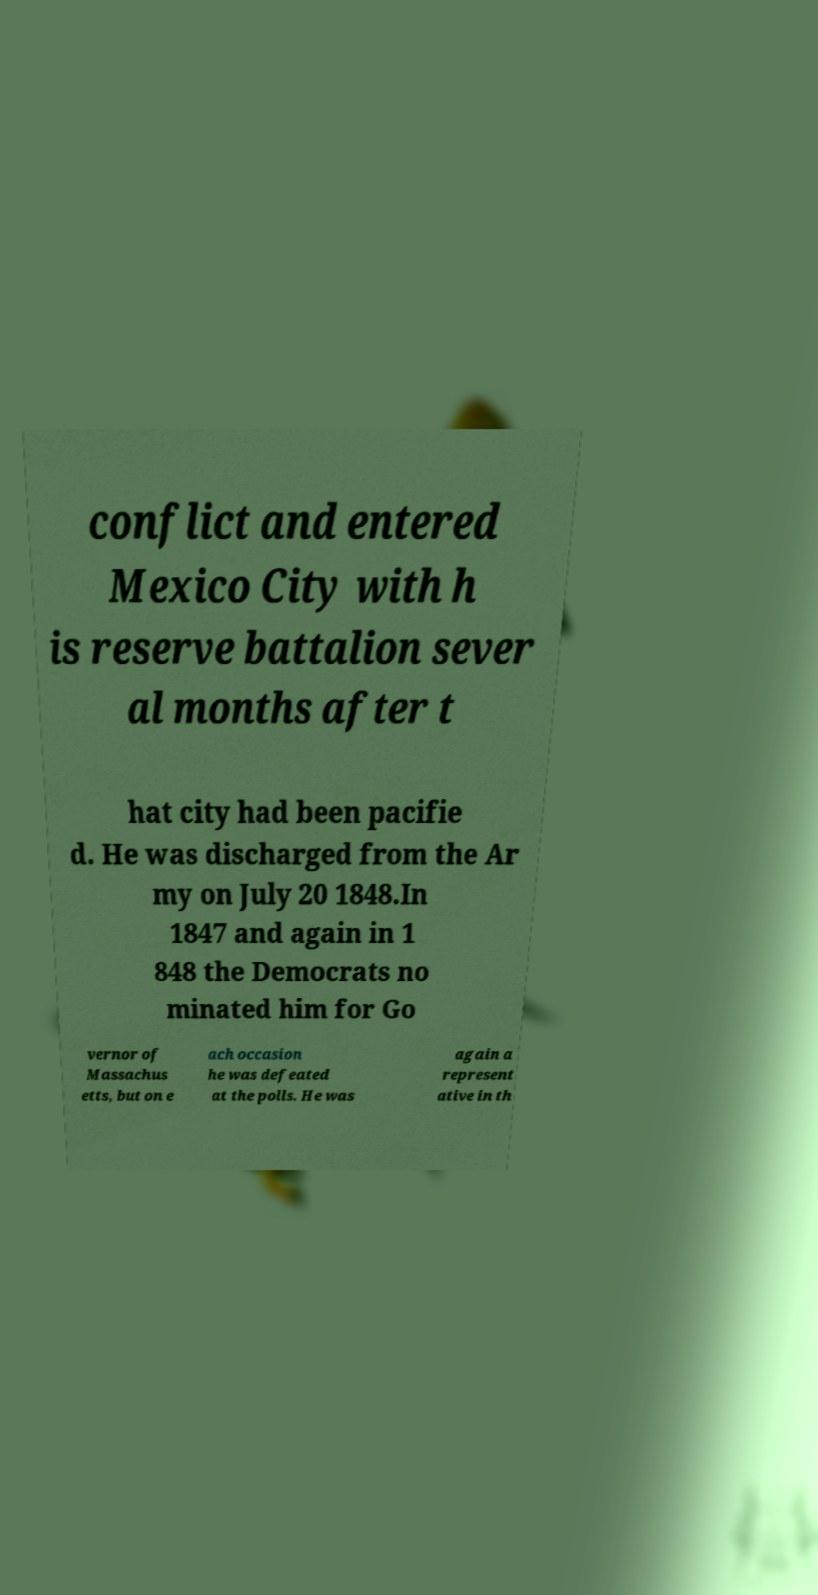Could you assist in decoding the text presented in this image and type it out clearly? conflict and entered Mexico City with h is reserve battalion sever al months after t hat city had been pacifie d. He was discharged from the Ar my on July 20 1848.In 1847 and again in 1 848 the Democrats no minated him for Go vernor of Massachus etts, but on e ach occasion he was defeated at the polls. He was again a represent ative in th 